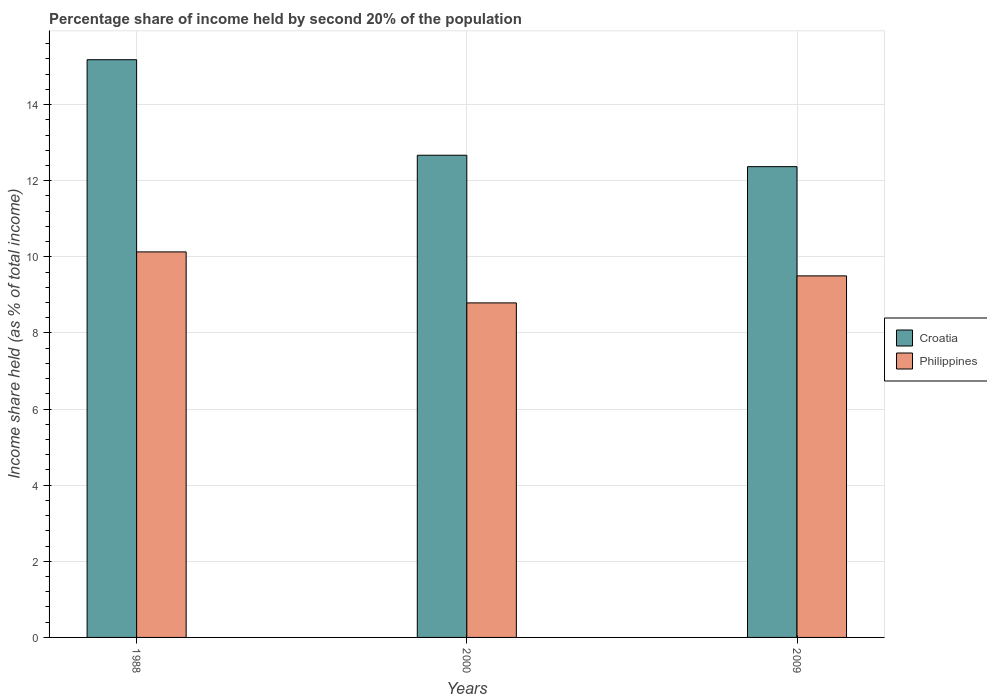How many different coloured bars are there?
Keep it short and to the point. 2. Are the number of bars per tick equal to the number of legend labels?
Keep it short and to the point. Yes. How many bars are there on the 2nd tick from the right?
Offer a very short reply. 2. What is the label of the 1st group of bars from the left?
Provide a succinct answer. 1988. What is the share of income held by second 20% of the population in Croatia in 1988?
Offer a terse response. 15.18. Across all years, what is the maximum share of income held by second 20% of the population in Croatia?
Offer a terse response. 15.18. Across all years, what is the minimum share of income held by second 20% of the population in Philippines?
Offer a very short reply. 8.79. In which year was the share of income held by second 20% of the population in Philippines minimum?
Ensure brevity in your answer.  2000. What is the total share of income held by second 20% of the population in Croatia in the graph?
Offer a terse response. 40.22. What is the difference between the share of income held by second 20% of the population in Croatia in 2000 and that in 2009?
Your answer should be very brief. 0.3. What is the difference between the share of income held by second 20% of the population in Croatia in 2000 and the share of income held by second 20% of the population in Philippines in 1988?
Provide a short and direct response. 2.54. What is the average share of income held by second 20% of the population in Philippines per year?
Provide a succinct answer. 9.47. In the year 2000, what is the difference between the share of income held by second 20% of the population in Croatia and share of income held by second 20% of the population in Philippines?
Ensure brevity in your answer.  3.88. In how many years, is the share of income held by second 20% of the population in Philippines greater than 0.4 %?
Your answer should be compact. 3. What is the ratio of the share of income held by second 20% of the population in Philippines in 2000 to that in 2009?
Offer a terse response. 0.93. Is the difference between the share of income held by second 20% of the population in Croatia in 2000 and 2009 greater than the difference between the share of income held by second 20% of the population in Philippines in 2000 and 2009?
Make the answer very short. Yes. What is the difference between the highest and the second highest share of income held by second 20% of the population in Philippines?
Ensure brevity in your answer.  0.63. What is the difference between the highest and the lowest share of income held by second 20% of the population in Croatia?
Offer a terse response. 2.81. In how many years, is the share of income held by second 20% of the population in Philippines greater than the average share of income held by second 20% of the population in Philippines taken over all years?
Provide a succinct answer. 2. Is the sum of the share of income held by second 20% of the population in Croatia in 1988 and 2000 greater than the maximum share of income held by second 20% of the population in Philippines across all years?
Your answer should be compact. Yes. What does the 1st bar from the left in 2000 represents?
Keep it short and to the point. Croatia. What does the 2nd bar from the right in 2000 represents?
Provide a short and direct response. Croatia. How many bars are there?
Your answer should be compact. 6. Are all the bars in the graph horizontal?
Make the answer very short. No. How many years are there in the graph?
Your answer should be very brief. 3. What is the difference between two consecutive major ticks on the Y-axis?
Ensure brevity in your answer.  2. Does the graph contain grids?
Make the answer very short. Yes. Where does the legend appear in the graph?
Your answer should be compact. Center right. How are the legend labels stacked?
Your answer should be very brief. Vertical. What is the title of the graph?
Offer a terse response. Percentage share of income held by second 20% of the population. Does "Ecuador" appear as one of the legend labels in the graph?
Make the answer very short. No. What is the label or title of the Y-axis?
Your answer should be very brief. Income share held (as % of total income). What is the Income share held (as % of total income) in Croatia in 1988?
Ensure brevity in your answer.  15.18. What is the Income share held (as % of total income) in Philippines in 1988?
Offer a very short reply. 10.13. What is the Income share held (as % of total income) of Croatia in 2000?
Give a very brief answer. 12.67. What is the Income share held (as % of total income) of Philippines in 2000?
Give a very brief answer. 8.79. What is the Income share held (as % of total income) of Croatia in 2009?
Your answer should be very brief. 12.37. What is the Income share held (as % of total income) in Philippines in 2009?
Keep it short and to the point. 9.5. Across all years, what is the maximum Income share held (as % of total income) in Croatia?
Offer a terse response. 15.18. Across all years, what is the maximum Income share held (as % of total income) in Philippines?
Ensure brevity in your answer.  10.13. Across all years, what is the minimum Income share held (as % of total income) in Croatia?
Offer a terse response. 12.37. Across all years, what is the minimum Income share held (as % of total income) in Philippines?
Your answer should be very brief. 8.79. What is the total Income share held (as % of total income) in Croatia in the graph?
Offer a very short reply. 40.22. What is the total Income share held (as % of total income) in Philippines in the graph?
Offer a very short reply. 28.42. What is the difference between the Income share held (as % of total income) of Croatia in 1988 and that in 2000?
Offer a very short reply. 2.51. What is the difference between the Income share held (as % of total income) in Philippines in 1988 and that in 2000?
Ensure brevity in your answer.  1.34. What is the difference between the Income share held (as % of total income) of Croatia in 1988 and that in 2009?
Ensure brevity in your answer.  2.81. What is the difference between the Income share held (as % of total income) of Philippines in 1988 and that in 2009?
Provide a short and direct response. 0.63. What is the difference between the Income share held (as % of total income) in Philippines in 2000 and that in 2009?
Your response must be concise. -0.71. What is the difference between the Income share held (as % of total income) of Croatia in 1988 and the Income share held (as % of total income) of Philippines in 2000?
Your response must be concise. 6.39. What is the difference between the Income share held (as % of total income) in Croatia in 1988 and the Income share held (as % of total income) in Philippines in 2009?
Your response must be concise. 5.68. What is the difference between the Income share held (as % of total income) in Croatia in 2000 and the Income share held (as % of total income) in Philippines in 2009?
Your response must be concise. 3.17. What is the average Income share held (as % of total income) of Croatia per year?
Give a very brief answer. 13.41. What is the average Income share held (as % of total income) of Philippines per year?
Your answer should be compact. 9.47. In the year 1988, what is the difference between the Income share held (as % of total income) of Croatia and Income share held (as % of total income) of Philippines?
Offer a very short reply. 5.05. In the year 2000, what is the difference between the Income share held (as % of total income) in Croatia and Income share held (as % of total income) in Philippines?
Your answer should be compact. 3.88. In the year 2009, what is the difference between the Income share held (as % of total income) of Croatia and Income share held (as % of total income) of Philippines?
Provide a short and direct response. 2.87. What is the ratio of the Income share held (as % of total income) of Croatia in 1988 to that in 2000?
Keep it short and to the point. 1.2. What is the ratio of the Income share held (as % of total income) in Philippines in 1988 to that in 2000?
Give a very brief answer. 1.15. What is the ratio of the Income share held (as % of total income) of Croatia in 1988 to that in 2009?
Offer a terse response. 1.23. What is the ratio of the Income share held (as % of total income) of Philippines in 1988 to that in 2009?
Your response must be concise. 1.07. What is the ratio of the Income share held (as % of total income) in Croatia in 2000 to that in 2009?
Give a very brief answer. 1.02. What is the ratio of the Income share held (as % of total income) of Philippines in 2000 to that in 2009?
Give a very brief answer. 0.93. What is the difference between the highest and the second highest Income share held (as % of total income) of Croatia?
Provide a short and direct response. 2.51. What is the difference between the highest and the second highest Income share held (as % of total income) in Philippines?
Make the answer very short. 0.63. What is the difference between the highest and the lowest Income share held (as % of total income) in Croatia?
Your response must be concise. 2.81. What is the difference between the highest and the lowest Income share held (as % of total income) of Philippines?
Your answer should be compact. 1.34. 